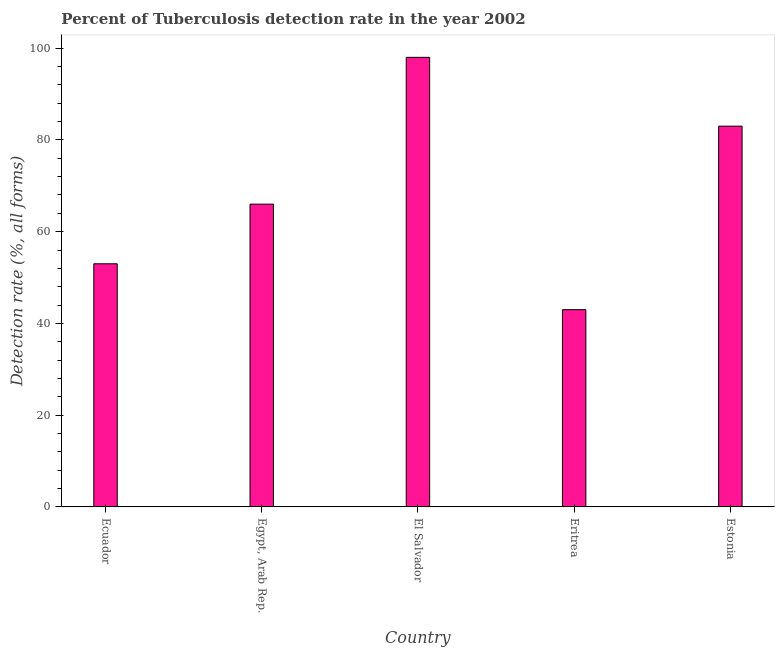Does the graph contain any zero values?
Your answer should be compact. No. What is the title of the graph?
Give a very brief answer. Percent of Tuberculosis detection rate in the year 2002. What is the label or title of the Y-axis?
Your response must be concise. Detection rate (%, all forms). What is the detection rate of tuberculosis in Estonia?
Provide a short and direct response. 83. Across all countries, what is the minimum detection rate of tuberculosis?
Offer a very short reply. 43. In which country was the detection rate of tuberculosis maximum?
Provide a succinct answer. El Salvador. In which country was the detection rate of tuberculosis minimum?
Your answer should be very brief. Eritrea. What is the sum of the detection rate of tuberculosis?
Your response must be concise. 343. What is the difference between the detection rate of tuberculosis in Ecuador and Estonia?
Your answer should be very brief. -30. What is the average detection rate of tuberculosis per country?
Make the answer very short. 68. What is the median detection rate of tuberculosis?
Your answer should be compact. 66. What is the ratio of the detection rate of tuberculosis in El Salvador to that in Estonia?
Provide a succinct answer. 1.18. Is the sum of the detection rate of tuberculosis in Ecuador and Egypt, Arab Rep. greater than the maximum detection rate of tuberculosis across all countries?
Your answer should be compact. Yes. What is the difference between two consecutive major ticks on the Y-axis?
Your answer should be compact. 20. Are the values on the major ticks of Y-axis written in scientific E-notation?
Make the answer very short. No. What is the Detection rate (%, all forms) of Ecuador?
Keep it short and to the point. 53. What is the Detection rate (%, all forms) in El Salvador?
Provide a succinct answer. 98. What is the Detection rate (%, all forms) in Estonia?
Provide a short and direct response. 83. What is the difference between the Detection rate (%, all forms) in Ecuador and El Salvador?
Keep it short and to the point. -45. What is the difference between the Detection rate (%, all forms) in Egypt, Arab Rep. and El Salvador?
Offer a terse response. -32. What is the difference between the Detection rate (%, all forms) in El Salvador and Eritrea?
Provide a succinct answer. 55. What is the ratio of the Detection rate (%, all forms) in Ecuador to that in Egypt, Arab Rep.?
Offer a terse response. 0.8. What is the ratio of the Detection rate (%, all forms) in Ecuador to that in El Salvador?
Your response must be concise. 0.54. What is the ratio of the Detection rate (%, all forms) in Ecuador to that in Eritrea?
Your answer should be very brief. 1.23. What is the ratio of the Detection rate (%, all forms) in Ecuador to that in Estonia?
Give a very brief answer. 0.64. What is the ratio of the Detection rate (%, all forms) in Egypt, Arab Rep. to that in El Salvador?
Make the answer very short. 0.67. What is the ratio of the Detection rate (%, all forms) in Egypt, Arab Rep. to that in Eritrea?
Give a very brief answer. 1.53. What is the ratio of the Detection rate (%, all forms) in Egypt, Arab Rep. to that in Estonia?
Keep it short and to the point. 0.8. What is the ratio of the Detection rate (%, all forms) in El Salvador to that in Eritrea?
Provide a short and direct response. 2.28. What is the ratio of the Detection rate (%, all forms) in El Salvador to that in Estonia?
Give a very brief answer. 1.18. What is the ratio of the Detection rate (%, all forms) in Eritrea to that in Estonia?
Keep it short and to the point. 0.52. 